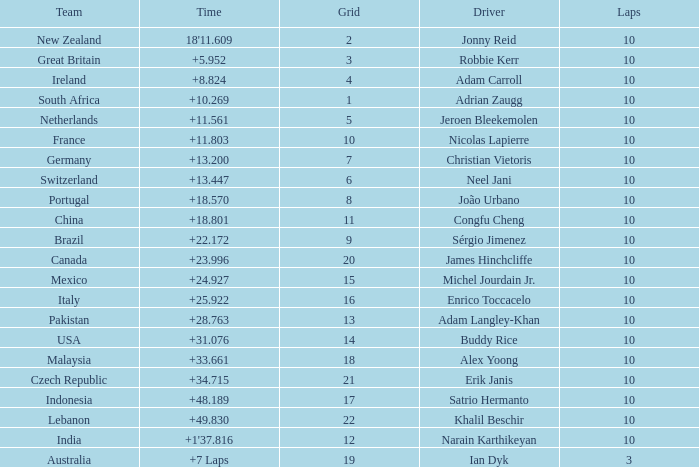For what Team is Narain Karthikeyan the Driver? India. 